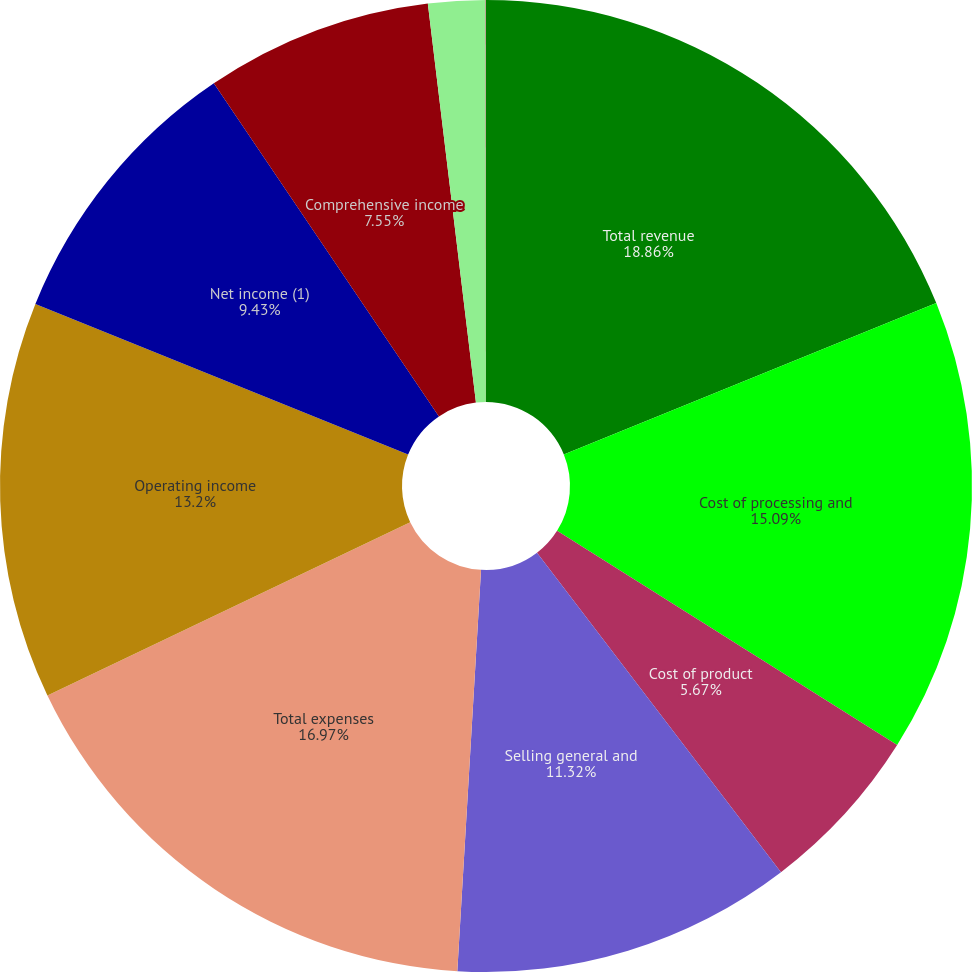Convert chart. <chart><loc_0><loc_0><loc_500><loc_500><pie_chart><fcel>Total revenue<fcel>Cost of processing and<fcel>Cost of product<fcel>Selling general and<fcel>Total expenses<fcel>Operating income<fcel>Net income (1)<fcel>Comprehensive income<fcel>Basic<fcel>Diluted<nl><fcel>18.86%<fcel>15.09%<fcel>5.67%<fcel>11.32%<fcel>16.97%<fcel>13.2%<fcel>9.43%<fcel>7.55%<fcel>1.9%<fcel>0.01%<nl></chart> 